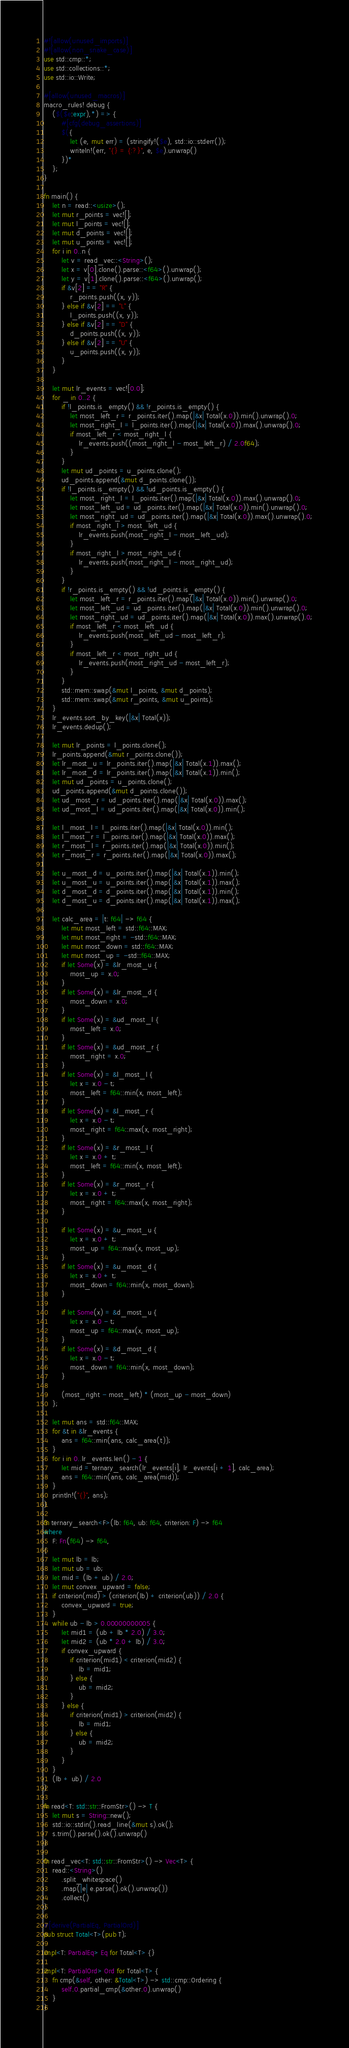Convert code to text. <code><loc_0><loc_0><loc_500><loc_500><_Rust_>#![allow(unused_imports)]
#![allow(non_snake_case)]
use std::cmp::*;
use std::collections::*;
use std::io::Write;

#[allow(unused_macros)]
macro_rules! debug {
    ($($e:expr),*) => {
        #[cfg(debug_assertions)]
        $({
            let (e, mut err) = (stringify!($e), std::io::stderr());
            writeln!(err, "{} = {:?}", e, $e).unwrap()
        })*
    };
}

fn main() {
    let n = read::<usize>();
    let mut r_points = vec![];
    let mut l_points = vec![];
    let mut d_points = vec![];
    let mut u_points = vec![];
    for i in 0..n {
        let v = read_vec::<String>();
        let x = v[0].clone().parse::<f64>().unwrap();
        let y = v[1].clone().parse::<f64>().unwrap();
        if &v[2] == "R" {
            r_points.push((x, y));
        } else if &v[2] == "L" {
            l_points.push((x, y));
        } else if &v[2] == "D" {
            d_points.push((x, y));
        } else if &v[2] == "U" {
            u_points.push((x, y));
        }
    }

    let mut lr_events = vec![0.0];
    for _ in 0..2 {
        if !l_points.is_empty() && !r_points.is_empty() {
            let most_left_r = r_points.iter().map(|&x| Total(x.0)).min().unwrap().0;
            let most_right_l = l_points.iter().map(|&x| Total(x.0)).max().unwrap().0;
            if most_left_r < most_right_l {
                lr_events.push((most_right_l - most_left_r) / 2.0f64);
            }
        }
        let mut ud_points = u_points.clone();
        ud_points.append(&mut d_points.clone());
        if !l_points.is_empty() && !ud_points.is_empty() {
            let most_right_l = l_points.iter().map(|&x| Total(x.0)).max().unwrap().0;
            let most_left_ud = ud_points.iter().map(|&x| Total(x.0)).min().unwrap().0;
            let most_right_ud = ud_points.iter().map(|&x| Total(x.0)).max().unwrap().0;
            if most_right_l > most_left_ud {
                lr_events.push(most_right_l - most_left_ud);
            }
            if most_right_l > most_right_ud {
                lr_events.push(most_right_l - most_right_ud);
            }
        }
        if !r_points.is_empty() && !ud_points.is_empty() {
            let most_left_r = r_points.iter().map(|&x| Total(x.0)).min().unwrap().0;
            let most_left_ud = ud_points.iter().map(|&x| Total(x.0)).min().unwrap().0;
            let most_right_ud = ud_points.iter().map(|&x| Total(x.0)).max().unwrap().0;
            if most_left_r < most_left_ud {
                lr_events.push(most_left_ud - most_left_r);
            }
            if most_left_r < most_right_ud {
                lr_events.push(most_right_ud - most_left_r);
            }
        }
        std::mem::swap(&mut l_points, &mut d_points);
        std::mem::swap(&mut r_points, &mut u_points);
    }
    lr_events.sort_by_key(|&x| Total(x));
    lr_events.dedup();

    let mut lr_points = l_points.clone();
    lr_points.append(&mut r_points.clone());
    let lr_most_u = lr_points.iter().map(|&x| Total(x.1)).max();
    let lr_most_d = lr_points.iter().map(|&x| Total(x.1)).min();
    let mut ud_points = u_points.clone();
    ud_points.append(&mut d_points.clone());
    let ud_most_r = ud_points.iter().map(|&x| Total(x.0)).max();
    let ud_most_l = ud_points.iter().map(|&x| Total(x.0)).min();

    let l_most_l = l_points.iter().map(|&x| Total(x.0)).min();
    let l_most_r = l_points.iter().map(|&x| Total(x.0)).max();
    let r_most_l = r_points.iter().map(|&x| Total(x.0)).min();
    let r_most_r = r_points.iter().map(|&x| Total(x.0)).max();

    let u_most_d = u_points.iter().map(|&x| Total(x.1)).min();
    let u_most_u = u_points.iter().map(|&x| Total(x.1)).max();
    let d_most_d = d_points.iter().map(|&x| Total(x.1)).min();
    let d_most_u = d_points.iter().map(|&x| Total(x.1)).max();

    let calc_area = |t: f64| -> f64 {
        let mut most_left = std::f64::MAX;
        let mut most_right = -std::f64::MAX;
        let mut most_down = std::f64::MAX;
        let mut most_up = -std::f64::MAX;
        if let Some(x) = &lr_most_u {
            most_up = x.0;
        }
        if let Some(x) = &lr_most_d {
            most_down = x.0;
        }
        if let Some(x) = &ud_most_l {
            most_left = x.0;
        }
        if let Some(x) = &ud_most_r {
            most_right = x.0;
        }
        if let Some(x) = &l_most_l {
            let x = x.0 - t;
            most_left = f64::min(x, most_left);
        }
        if let Some(x) = &l_most_r {
            let x = x.0 - t;
            most_right = f64::max(x, most_right);
        }
        if let Some(x) = &r_most_l {
            let x = x.0 + t;
            most_left = f64::min(x, most_left);
        }
        if let Some(x) = &r_most_r {
            let x = x.0 + t;
            most_right = f64::max(x, most_right);
        }

        if let Some(x) = &u_most_u {
            let x = x.0 + t;
            most_up = f64::max(x, most_up);
        }
        if let Some(x) = &u_most_d {
            let x = x.0 + t;
            most_down = f64::min(x, most_down);
        }

        if let Some(x) = &d_most_u {
            let x = x.0 - t;
            most_up = f64::max(x, most_up);
        }
        if let Some(x) = &d_most_d {
            let x = x.0 - t;
            most_down = f64::min(x, most_down);
        }

        (most_right - most_left) * (most_up - most_down)
    };

    let mut ans = std::f64::MAX;
    for &t in &lr_events {
        ans = f64::min(ans, calc_area(t));
    }
    for i in 0..lr_events.len() - 1 {
        let mid = ternary_search(lr_events[i], lr_events[i + 1], calc_area);
        ans = f64::min(ans, calc_area(mid));
    }
    println!("{}", ans);
}

fn ternary_search<F>(lb: f64, ub: f64, criterion: F) -> f64
where
    F: Fn(f64) -> f64,
{
    let mut lb = lb;
    let mut ub = ub;
    let mid = (lb + ub) / 2.0;
    let mut convex_upward = false;
    if criterion(mid) > (criterion(lb) + criterion(ub)) / 2.0 {
        convex_upward = true;
    }
    while ub - lb > 0.00000000005 {
        let mid1 = (ub + lb * 2.0) / 3.0;
        let mid2 = (ub * 2.0 + lb) / 3.0;
        if convex_upward {
            if criterion(mid1) < criterion(mid2) {
                lb = mid1;
            } else {
                ub = mid2;
            }
        } else {
            if criterion(mid1) > criterion(mid2) {
                lb = mid1;
            } else {
                ub = mid2;
            }
        }
    }
    (lb + ub) / 2.0
}

fn read<T: std::str::FromStr>() -> T {
    let mut s = String::new();
    std::io::stdin().read_line(&mut s).ok();
    s.trim().parse().ok().unwrap()
}

fn read_vec<T: std::str::FromStr>() -> Vec<T> {
    read::<String>()
        .split_whitespace()
        .map(|e| e.parse().ok().unwrap())
        .collect()
}

#[derive(PartialEq, PartialOrd)]
pub struct Total<T>(pub T);

impl<T: PartialEq> Eq for Total<T> {}

impl<T: PartialOrd> Ord for Total<T> {
    fn cmp(&self, other: &Total<T>) -> std::cmp::Ordering {
        self.0.partial_cmp(&other.0).unwrap()
    }
}
</code> 